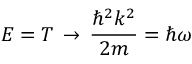Convert formula to latex. <formula><loc_0><loc_0><loc_500><loc_500>E = T \, \rightarrow \, { \frac { \hbar { ^ } { 2 } k ^ { 2 } } { 2 m } } = \hbar { \omega }</formula> 